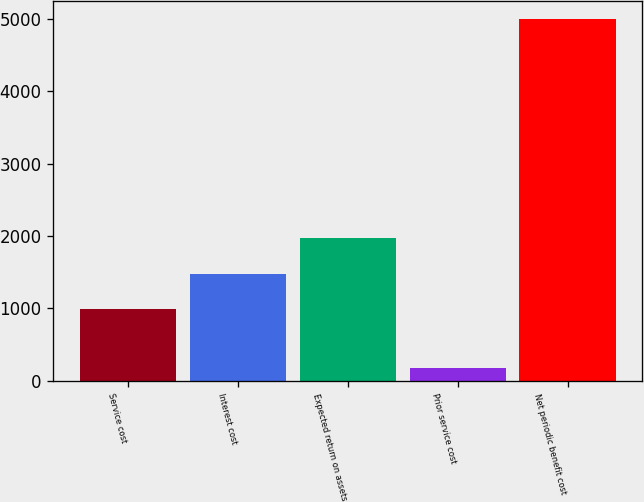<chart> <loc_0><loc_0><loc_500><loc_500><bar_chart><fcel>Service cost<fcel>Interest cost<fcel>Expected return on assets<fcel>Prior service cost<fcel>Net periodic benefit cost<nl><fcel>998<fcel>1480.6<fcel>1970<fcel>173<fcel>4999<nl></chart> 